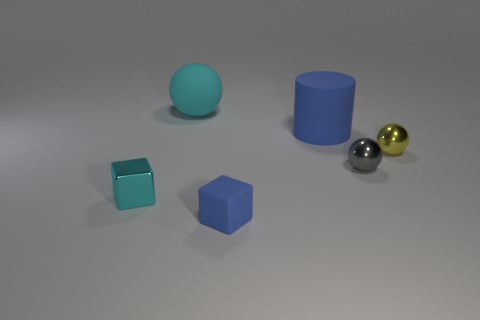What material is the block that is the same color as the matte ball?
Offer a very short reply. Metal. Is the matte sphere the same color as the metallic block?
Give a very brief answer. Yes. What is the size of the object that is both behind the small yellow metallic object and left of the tiny blue matte thing?
Offer a terse response. Large. There is a small metal object that is to the right of the cyan sphere and in front of the yellow sphere; what color is it?
Give a very brief answer. Gray. Are there fewer large blue rubber objects on the left side of the big matte sphere than tiny metal objects behind the small gray ball?
Keep it short and to the point. Yes. How many other tiny shiny objects are the same shape as the yellow thing?
Ensure brevity in your answer.  1. What is the size of the block that is made of the same material as the big ball?
Make the answer very short. Small. What is the color of the tiny block that is to the right of the sphere behind the rubber cylinder?
Make the answer very short. Blue. There is a small rubber thing; is its shape the same as the large thing to the right of the rubber sphere?
Provide a short and direct response. No. What number of gray shiny balls have the same size as the rubber block?
Your answer should be very brief. 1. 